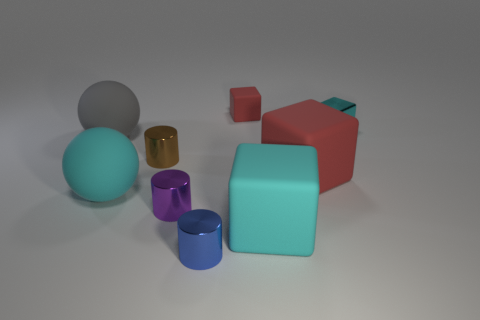What number of blue metallic objects have the same size as the brown metallic cylinder?
Ensure brevity in your answer.  1. What number of gray objects are matte things or cylinders?
Keep it short and to the point. 1. There is a large cyan object that is on the left side of the cyan rubber thing that is in front of the large cyan ball; what shape is it?
Provide a short and direct response. Sphere. There is a blue metallic object that is the same size as the brown shiny thing; what shape is it?
Keep it short and to the point. Cylinder. Is there a large matte cube that has the same color as the tiny metallic cube?
Provide a succinct answer. Yes. Is the number of blue metallic things in front of the gray ball the same as the number of small blue metallic objects that are in front of the brown metallic thing?
Ensure brevity in your answer.  Yes. Do the small rubber object and the red rubber thing that is in front of the small cyan metallic block have the same shape?
Keep it short and to the point. Yes. How many other objects are the same material as the large gray ball?
Offer a terse response. 4. There is a purple metal object; are there any small brown cylinders in front of it?
Provide a short and direct response. No. There is a blue shiny thing; is its size the same as the cube to the left of the big cyan block?
Offer a very short reply. Yes. 